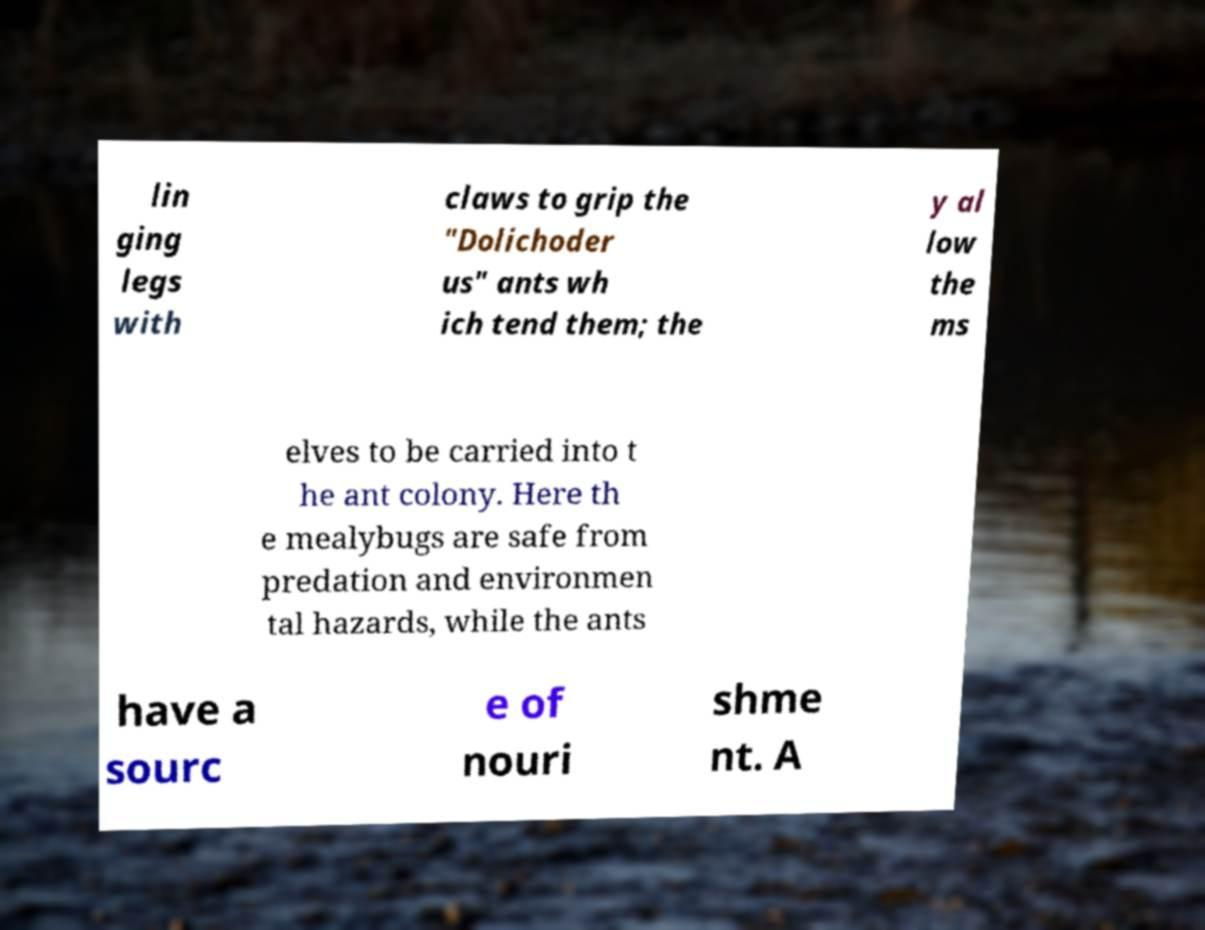Could you extract and type out the text from this image? lin ging legs with claws to grip the "Dolichoder us" ants wh ich tend them; the y al low the ms elves to be carried into t he ant colony. Here th e mealybugs are safe from predation and environmen tal hazards, while the ants have a sourc e of nouri shme nt. A 